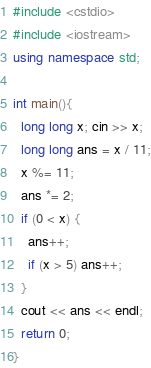Convert code to text. <code><loc_0><loc_0><loc_500><loc_500><_C++_>#include <cstdio>
#include <iostream>
using namespace std;

int main(){
  long long x; cin >> x;
  long long ans = x / 11;
  x %= 11;
  ans *= 2;
  if (0 < x) {
    ans++;
    if (x > 5) ans++;
  }
  cout << ans << endl;
  return 0;
}
</code> 